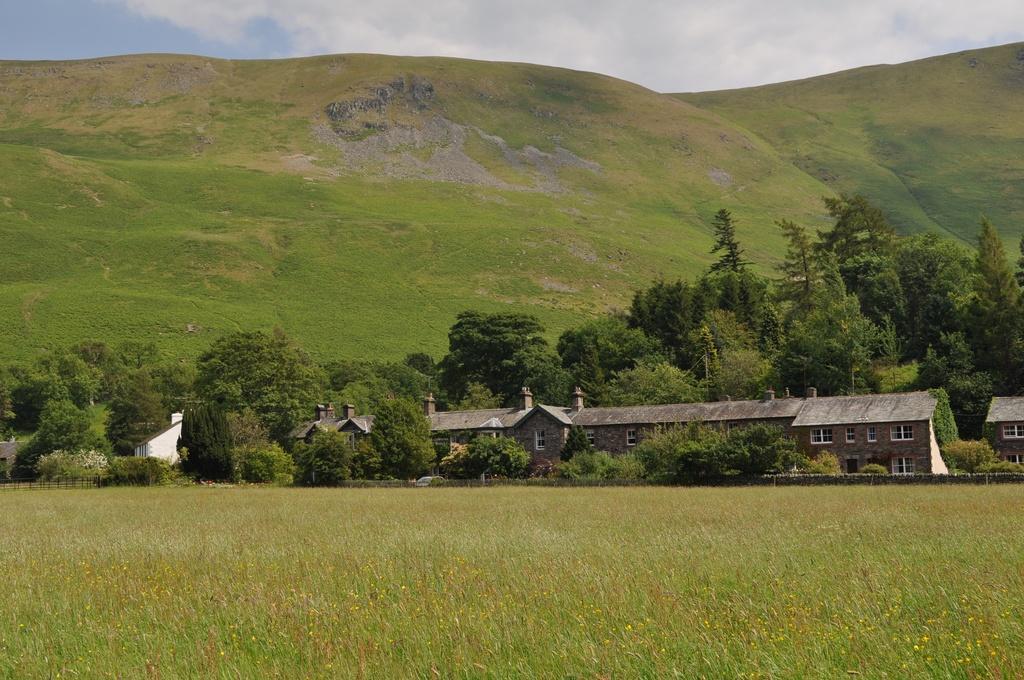Can you describe this image briefly? In the foreground of the image we can see the grass. In the middle of image we can see building, trees and grass. On the top of the image we can see clouds and the sky. 